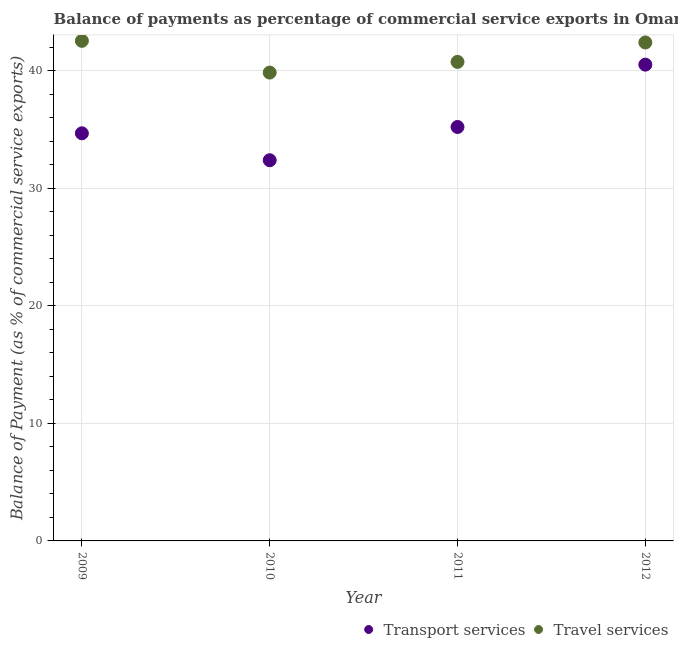Is the number of dotlines equal to the number of legend labels?
Your answer should be very brief. Yes. What is the balance of payments of transport services in 2011?
Ensure brevity in your answer.  35.21. Across all years, what is the maximum balance of payments of travel services?
Give a very brief answer. 42.54. Across all years, what is the minimum balance of payments of travel services?
Provide a succinct answer. 39.84. What is the total balance of payments of transport services in the graph?
Provide a succinct answer. 142.78. What is the difference between the balance of payments of transport services in 2009 and that in 2011?
Provide a succinct answer. -0.54. What is the difference between the balance of payments of transport services in 2011 and the balance of payments of travel services in 2010?
Your answer should be very brief. -4.63. What is the average balance of payments of transport services per year?
Give a very brief answer. 35.69. In the year 2011, what is the difference between the balance of payments of travel services and balance of payments of transport services?
Offer a terse response. 5.54. In how many years, is the balance of payments of transport services greater than 20 %?
Give a very brief answer. 4. What is the ratio of the balance of payments of travel services in 2009 to that in 2012?
Give a very brief answer. 1. Is the difference between the balance of payments of transport services in 2009 and 2011 greater than the difference between the balance of payments of travel services in 2009 and 2011?
Your answer should be very brief. No. What is the difference between the highest and the second highest balance of payments of transport services?
Offer a very short reply. 5.3. What is the difference between the highest and the lowest balance of payments of transport services?
Keep it short and to the point. 8.13. Does the balance of payments of travel services monotonically increase over the years?
Keep it short and to the point. No. Is the balance of payments of travel services strictly greater than the balance of payments of transport services over the years?
Your answer should be compact. Yes. How many years are there in the graph?
Offer a terse response. 4. Does the graph contain grids?
Offer a very short reply. Yes. Where does the legend appear in the graph?
Provide a succinct answer. Bottom right. What is the title of the graph?
Ensure brevity in your answer.  Balance of payments as percentage of commercial service exports in Oman. What is the label or title of the X-axis?
Offer a very short reply. Year. What is the label or title of the Y-axis?
Give a very brief answer. Balance of Payment (as % of commercial service exports). What is the Balance of Payment (as % of commercial service exports) of Transport services in 2009?
Offer a very short reply. 34.67. What is the Balance of Payment (as % of commercial service exports) in Travel services in 2009?
Provide a short and direct response. 42.54. What is the Balance of Payment (as % of commercial service exports) in Transport services in 2010?
Your answer should be compact. 32.38. What is the Balance of Payment (as % of commercial service exports) in Travel services in 2010?
Offer a terse response. 39.84. What is the Balance of Payment (as % of commercial service exports) of Transport services in 2011?
Provide a short and direct response. 35.21. What is the Balance of Payment (as % of commercial service exports) in Travel services in 2011?
Your response must be concise. 40.75. What is the Balance of Payment (as % of commercial service exports) in Transport services in 2012?
Offer a very short reply. 40.51. What is the Balance of Payment (as % of commercial service exports) in Travel services in 2012?
Your answer should be compact. 42.4. Across all years, what is the maximum Balance of Payment (as % of commercial service exports) in Transport services?
Make the answer very short. 40.51. Across all years, what is the maximum Balance of Payment (as % of commercial service exports) of Travel services?
Make the answer very short. 42.54. Across all years, what is the minimum Balance of Payment (as % of commercial service exports) in Transport services?
Your response must be concise. 32.38. Across all years, what is the minimum Balance of Payment (as % of commercial service exports) in Travel services?
Ensure brevity in your answer.  39.84. What is the total Balance of Payment (as % of commercial service exports) of Transport services in the graph?
Your answer should be very brief. 142.78. What is the total Balance of Payment (as % of commercial service exports) of Travel services in the graph?
Give a very brief answer. 165.51. What is the difference between the Balance of Payment (as % of commercial service exports) of Transport services in 2009 and that in 2010?
Provide a short and direct response. 2.29. What is the difference between the Balance of Payment (as % of commercial service exports) in Travel services in 2009 and that in 2010?
Your answer should be very brief. 2.7. What is the difference between the Balance of Payment (as % of commercial service exports) in Transport services in 2009 and that in 2011?
Offer a very short reply. -0.54. What is the difference between the Balance of Payment (as % of commercial service exports) in Travel services in 2009 and that in 2011?
Your response must be concise. 1.79. What is the difference between the Balance of Payment (as % of commercial service exports) in Transport services in 2009 and that in 2012?
Your answer should be compact. -5.84. What is the difference between the Balance of Payment (as % of commercial service exports) in Travel services in 2009 and that in 2012?
Your answer should be very brief. 0.14. What is the difference between the Balance of Payment (as % of commercial service exports) of Transport services in 2010 and that in 2011?
Ensure brevity in your answer.  -2.83. What is the difference between the Balance of Payment (as % of commercial service exports) of Travel services in 2010 and that in 2011?
Provide a short and direct response. -0.91. What is the difference between the Balance of Payment (as % of commercial service exports) in Transport services in 2010 and that in 2012?
Give a very brief answer. -8.13. What is the difference between the Balance of Payment (as % of commercial service exports) in Travel services in 2010 and that in 2012?
Your answer should be very brief. -2.56. What is the difference between the Balance of Payment (as % of commercial service exports) of Transport services in 2011 and that in 2012?
Offer a very short reply. -5.3. What is the difference between the Balance of Payment (as % of commercial service exports) in Travel services in 2011 and that in 2012?
Provide a short and direct response. -1.65. What is the difference between the Balance of Payment (as % of commercial service exports) in Transport services in 2009 and the Balance of Payment (as % of commercial service exports) in Travel services in 2010?
Give a very brief answer. -5.17. What is the difference between the Balance of Payment (as % of commercial service exports) of Transport services in 2009 and the Balance of Payment (as % of commercial service exports) of Travel services in 2011?
Your answer should be very brief. -6.07. What is the difference between the Balance of Payment (as % of commercial service exports) in Transport services in 2009 and the Balance of Payment (as % of commercial service exports) in Travel services in 2012?
Your answer should be compact. -7.73. What is the difference between the Balance of Payment (as % of commercial service exports) of Transport services in 2010 and the Balance of Payment (as % of commercial service exports) of Travel services in 2011?
Ensure brevity in your answer.  -8.36. What is the difference between the Balance of Payment (as % of commercial service exports) in Transport services in 2010 and the Balance of Payment (as % of commercial service exports) in Travel services in 2012?
Your answer should be compact. -10.02. What is the difference between the Balance of Payment (as % of commercial service exports) in Transport services in 2011 and the Balance of Payment (as % of commercial service exports) in Travel services in 2012?
Keep it short and to the point. -7.19. What is the average Balance of Payment (as % of commercial service exports) of Transport services per year?
Offer a terse response. 35.69. What is the average Balance of Payment (as % of commercial service exports) of Travel services per year?
Give a very brief answer. 41.38. In the year 2009, what is the difference between the Balance of Payment (as % of commercial service exports) of Transport services and Balance of Payment (as % of commercial service exports) of Travel services?
Keep it short and to the point. -7.87. In the year 2010, what is the difference between the Balance of Payment (as % of commercial service exports) of Transport services and Balance of Payment (as % of commercial service exports) of Travel services?
Provide a short and direct response. -7.46. In the year 2011, what is the difference between the Balance of Payment (as % of commercial service exports) of Transport services and Balance of Payment (as % of commercial service exports) of Travel services?
Give a very brief answer. -5.54. In the year 2012, what is the difference between the Balance of Payment (as % of commercial service exports) of Transport services and Balance of Payment (as % of commercial service exports) of Travel services?
Provide a succinct answer. -1.88. What is the ratio of the Balance of Payment (as % of commercial service exports) in Transport services in 2009 to that in 2010?
Your answer should be very brief. 1.07. What is the ratio of the Balance of Payment (as % of commercial service exports) in Travel services in 2009 to that in 2010?
Ensure brevity in your answer.  1.07. What is the ratio of the Balance of Payment (as % of commercial service exports) in Transport services in 2009 to that in 2011?
Ensure brevity in your answer.  0.98. What is the ratio of the Balance of Payment (as % of commercial service exports) of Travel services in 2009 to that in 2011?
Offer a very short reply. 1.04. What is the ratio of the Balance of Payment (as % of commercial service exports) in Transport services in 2009 to that in 2012?
Offer a very short reply. 0.86. What is the ratio of the Balance of Payment (as % of commercial service exports) of Travel services in 2009 to that in 2012?
Ensure brevity in your answer.  1. What is the ratio of the Balance of Payment (as % of commercial service exports) of Transport services in 2010 to that in 2011?
Ensure brevity in your answer.  0.92. What is the ratio of the Balance of Payment (as % of commercial service exports) of Travel services in 2010 to that in 2011?
Offer a very short reply. 0.98. What is the ratio of the Balance of Payment (as % of commercial service exports) of Transport services in 2010 to that in 2012?
Offer a very short reply. 0.8. What is the ratio of the Balance of Payment (as % of commercial service exports) of Travel services in 2010 to that in 2012?
Keep it short and to the point. 0.94. What is the ratio of the Balance of Payment (as % of commercial service exports) of Transport services in 2011 to that in 2012?
Make the answer very short. 0.87. What is the ratio of the Balance of Payment (as % of commercial service exports) of Travel services in 2011 to that in 2012?
Offer a very short reply. 0.96. What is the difference between the highest and the second highest Balance of Payment (as % of commercial service exports) in Transport services?
Provide a succinct answer. 5.3. What is the difference between the highest and the second highest Balance of Payment (as % of commercial service exports) of Travel services?
Make the answer very short. 0.14. What is the difference between the highest and the lowest Balance of Payment (as % of commercial service exports) of Transport services?
Your response must be concise. 8.13. What is the difference between the highest and the lowest Balance of Payment (as % of commercial service exports) in Travel services?
Offer a very short reply. 2.7. 